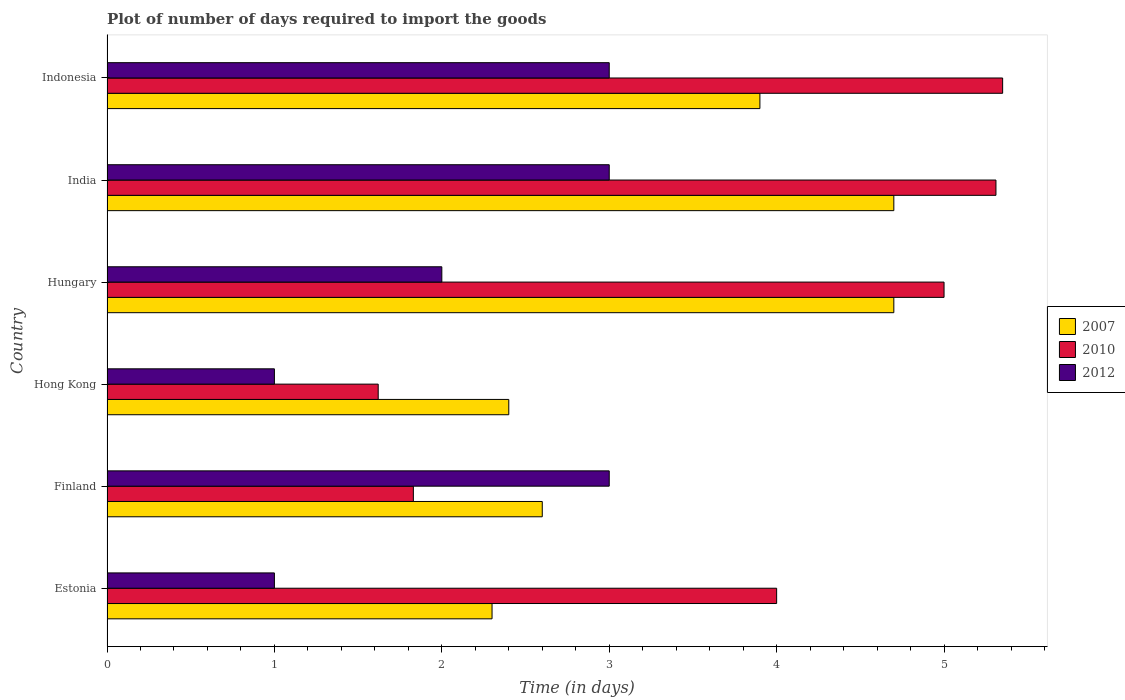How many different coloured bars are there?
Ensure brevity in your answer.  3. How many groups of bars are there?
Offer a terse response. 6. Are the number of bars per tick equal to the number of legend labels?
Provide a short and direct response. Yes. What is the label of the 6th group of bars from the top?
Keep it short and to the point. Estonia. What is the time required to import goods in 2010 in Finland?
Give a very brief answer. 1.83. Across all countries, what is the minimum time required to import goods in 2007?
Provide a succinct answer. 2.3. In which country was the time required to import goods in 2007 minimum?
Ensure brevity in your answer.  Estonia. What is the total time required to import goods in 2007 in the graph?
Make the answer very short. 20.6. What is the difference between the time required to import goods in 2010 in Estonia and that in India?
Your response must be concise. -1.31. What is the difference between the time required to import goods in 2007 in Hong Kong and the time required to import goods in 2012 in Hungary?
Your answer should be compact. 0.4. What is the average time required to import goods in 2007 per country?
Give a very brief answer. 3.43. What is the difference between the time required to import goods in 2012 and time required to import goods in 2007 in India?
Your answer should be compact. -1.7. In how many countries, is the time required to import goods in 2012 greater than 3 days?
Make the answer very short. 0. What is the ratio of the time required to import goods in 2007 in India to that in Indonesia?
Offer a terse response. 1.21. Is the time required to import goods in 2007 in Estonia less than that in Indonesia?
Offer a terse response. Yes. What is the difference between the highest and the second highest time required to import goods in 2007?
Offer a very short reply. 0. What is the difference between the highest and the lowest time required to import goods in 2012?
Make the answer very short. 2. What does the 1st bar from the top in Hong Kong represents?
Give a very brief answer. 2012. What does the 1st bar from the bottom in Hungary represents?
Offer a very short reply. 2007. Where does the legend appear in the graph?
Keep it short and to the point. Center right. How many legend labels are there?
Ensure brevity in your answer.  3. What is the title of the graph?
Make the answer very short. Plot of number of days required to import the goods. Does "1975" appear as one of the legend labels in the graph?
Offer a very short reply. No. What is the label or title of the X-axis?
Offer a very short reply. Time (in days). What is the label or title of the Y-axis?
Make the answer very short. Country. What is the Time (in days) of 2007 in Estonia?
Keep it short and to the point. 2.3. What is the Time (in days) in 2010 in Estonia?
Your answer should be compact. 4. What is the Time (in days) in 2010 in Finland?
Provide a succinct answer. 1.83. What is the Time (in days) in 2010 in Hong Kong?
Ensure brevity in your answer.  1.62. What is the Time (in days) in 2012 in Hong Kong?
Provide a short and direct response. 1. What is the Time (in days) of 2007 in India?
Provide a short and direct response. 4.7. What is the Time (in days) of 2010 in India?
Give a very brief answer. 5.31. What is the Time (in days) in 2012 in India?
Give a very brief answer. 3. What is the Time (in days) in 2007 in Indonesia?
Your response must be concise. 3.9. What is the Time (in days) in 2010 in Indonesia?
Ensure brevity in your answer.  5.35. Across all countries, what is the maximum Time (in days) in 2007?
Keep it short and to the point. 4.7. Across all countries, what is the maximum Time (in days) of 2010?
Provide a succinct answer. 5.35. Across all countries, what is the minimum Time (in days) of 2007?
Provide a short and direct response. 2.3. Across all countries, what is the minimum Time (in days) in 2010?
Your answer should be very brief. 1.62. Across all countries, what is the minimum Time (in days) in 2012?
Offer a terse response. 1. What is the total Time (in days) of 2007 in the graph?
Give a very brief answer. 20.6. What is the total Time (in days) in 2010 in the graph?
Offer a very short reply. 23.11. What is the total Time (in days) of 2012 in the graph?
Ensure brevity in your answer.  13. What is the difference between the Time (in days) in 2007 in Estonia and that in Finland?
Your answer should be very brief. -0.3. What is the difference between the Time (in days) in 2010 in Estonia and that in Finland?
Make the answer very short. 2.17. What is the difference between the Time (in days) in 2012 in Estonia and that in Finland?
Give a very brief answer. -2. What is the difference between the Time (in days) in 2010 in Estonia and that in Hong Kong?
Offer a very short reply. 2.38. What is the difference between the Time (in days) in 2010 in Estonia and that in Hungary?
Make the answer very short. -1. What is the difference between the Time (in days) in 2012 in Estonia and that in Hungary?
Your answer should be very brief. -1. What is the difference between the Time (in days) in 2007 in Estonia and that in India?
Give a very brief answer. -2.4. What is the difference between the Time (in days) of 2010 in Estonia and that in India?
Your answer should be compact. -1.31. What is the difference between the Time (in days) in 2012 in Estonia and that in India?
Make the answer very short. -2. What is the difference between the Time (in days) in 2010 in Estonia and that in Indonesia?
Give a very brief answer. -1.35. What is the difference between the Time (in days) in 2012 in Estonia and that in Indonesia?
Make the answer very short. -2. What is the difference between the Time (in days) of 2007 in Finland and that in Hong Kong?
Your answer should be compact. 0.2. What is the difference between the Time (in days) of 2010 in Finland and that in Hong Kong?
Your answer should be very brief. 0.21. What is the difference between the Time (in days) in 2010 in Finland and that in Hungary?
Keep it short and to the point. -3.17. What is the difference between the Time (in days) of 2010 in Finland and that in India?
Offer a terse response. -3.48. What is the difference between the Time (in days) of 2010 in Finland and that in Indonesia?
Offer a very short reply. -3.52. What is the difference between the Time (in days) of 2007 in Hong Kong and that in Hungary?
Offer a terse response. -2.3. What is the difference between the Time (in days) in 2010 in Hong Kong and that in Hungary?
Your answer should be compact. -3.38. What is the difference between the Time (in days) in 2007 in Hong Kong and that in India?
Give a very brief answer. -2.3. What is the difference between the Time (in days) of 2010 in Hong Kong and that in India?
Your answer should be very brief. -3.69. What is the difference between the Time (in days) of 2007 in Hong Kong and that in Indonesia?
Offer a terse response. -1.5. What is the difference between the Time (in days) of 2010 in Hong Kong and that in Indonesia?
Make the answer very short. -3.73. What is the difference between the Time (in days) in 2007 in Hungary and that in India?
Provide a short and direct response. 0. What is the difference between the Time (in days) of 2010 in Hungary and that in India?
Provide a short and direct response. -0.31. What is the difference between the Time (in days) of 2012 in Hungary and that in India?
Offer a terse response. -1. What is the difference between the Time (in days) in 2010 in Hungary and that in Indonesia?
Ensure brevity in your answer.  -0.35. What is the difference between the Time (in days) in 2010 in India and that in Indonesia?
Offer a terse response. -0.04. What is the difference between the Time (in days) in 2012 in India and that in Indonesia?
Your answer should be very brief. 0. What is the difference between the Time (in days) in 2007 in Estonia and the Time (in days) in 2010 in Finland?
Give a very brief answer. 0.47. What is the difference between the Time (in days) in 2007 in Estonia and the Time (in days) in 2012 in Finland?
Provide a short and direct response. -0.7. What is the difference between the Time (in days) in 2010 in Estonia and the Time (in days) in 2012 in Finland?
Provide a succinct answer. 1. What is the difference between the Time (in days) in 2007 in Estonia and the Time (in days) in 2010 in Hong Kong?
Give a very brief answer. 0.68. What is the difference between the Time (in days) of 2007 in Estonia and the Time (in days) of 2010 in Hungary?
Provide a short and direct response. -2.7. What is the difference between the Time (in days) of 2007 in Estonia and the Time (in days) of 2010 in India?
Ensure brevity in your answer.  -3.01. What is the difference between the Time (in days) in 2010 in Estonia and the Time (in days) in 2012 in India?
Your answer should be compact. 1. What is the difference between the Time (in days) of 2007 in Estonia and the Time (in days) of 2010 in Indonesia?
Your answer should be very brief. -3.05. What is the difference between the Time (in days) in 2007 in Estonia and the Time (in days) in 2012 in Indonesia?
Ensure brevity in your answer.  -0.7. What is the difference between the Time (in days) of 2010 in Estonia and the Time (in days) of 2012 in Indonesia?
Ensure brevity in your answer.  1. What is the difference between the Time (in days) of 2007 in Finland and the Time (in days) of 2010 in Hong Kong?
Make the answer very short. 0.98. What is the difference between the Time (in days) of 2007 in Finland and the Time (in days) of 2012 in Hong Kong?
Give a very brief answer. 1.6. What is the difference between the Time (in days) of 2010 in Finland and the Time (in days) of 2012 in Hong Kong?
Ensure brevity in your answer.  0.83. What is the difference between the Time (in days) of 2007 in Finland and the Time (in days) of 2012 in Hungary?
Offer a terse response. 0.6. What is the difference between the Time (in days) in 2010 in Finland and the Time (in days) in 2012 in Hungary?
Your response must be concise. -0.17. What is the difference between the Time (in days) of 2007 in Finland and the Time (in days) of 2010 in India?
Ensure brevity in your answer.  -2.71. What is the difference between the Time (in days) of 2010 in Finland and the Time (in days) of 2012 in India?
Provide a short and direct response. -1.17. What is the difference between the Time (in days) of 2007 in Finland and the Time (in days) of 2010 in Indonesia?
Your response must be concise. -2.75. What is the difference between the Time (in days) in 2010 in Finland and the Time (in days) in 2012 in Indonesia?
Keep it short and to the point. -1.17. What is the difference between the Time (in days) of 2007 in Hong Kong and the Time (in days) of 2012 in Hungary?
Make the answer very short. 0.4. What is the difference between the Time (in days) in 2010 in Hong Kong and the Time (in days) in 2012 in Hungary?
Your answer should be compact. -0.38. What is the difference between the Time (in days) in 2007 in Hong Kong and the Time (in days) in 2010 in India?
Offer a terse response. -2.91. What is the difference between the Time (in days) of 2010 in Hong Kong and the Time (in days) of 2012 in India?
Make the answer very short. -1.38. What is the difference between the Time (in days) in 2007 in Hong Kong and the Time (in days) in 2010 in Indonesia?
Give a very brief answer. -2.95. What is the difference between the Time (in days) of 2007 in Hong Kong and the Time (in days) of 2012 in Indonesia?
Offer a very short reply. -0.6. What is the difference between the Time (in days) of 2010 in Hong Kong and the Time (in days) of 2012 in Indonesia?
Provide a succinct answer. -1.38. What is the difference between the Time (in days) of 2007 in Hungary and the Time (in days) of 2010 in India?
Ensure brevity in your answer.  -0.61. What is the difference between the Time (in days) of 2007 in Hungary and the Time (in days) of 2010 in Indonesia?
Give a very brief answer. -0.65. What is the difference between the Time (in days) of 2007 in Hungary and the Time (in days) of 2012 in Indonesia?
Ensure brevity in your answer.  1.7. What is the difference between the Time (in days) of 2010 in Hungary and the Time (in days) of 2012 in Indonesia?
Offer a very short reply. 2. What is the difference between the Time (in days) of 2007 in India and the Time (in days) of 2010 in Indonesia?
Ensure brevity in your answer.  -0.65. What is the difference between the Time (in days) of 2007 in India and the Time (in days) of 2012 in Indonesia?
Provide a succinct answer. 1.7. What is the difference between the Time (in days) of 2010 in India and the Time (in days) of 2012 in Indonesia?
Ensure brevity in your answer.  2.31. What is the average Time (in days) of 2007 per country?
Offer a very short reply. 3.43. What is the average Time (in days) of 2010 per country?
Give a very brief answer. 3.85. What is the average Time (in days) of 2012 per country?
Provide a short and direct response. 2.17. What is the difference between the Time (in days) of 2007 and Time (in days) of 2010 in Finland?
Make the answer very short. 0.77. What is the difference between the Time (in days) in 2007 and Time (in days) in 2012 in Finland?
Make the answer very short. -0.4. What is the difference between the Time (in days) of 2010 and Time (in days) of 2012 in Finland?
Ensure brevity in your answer.  -1.17. What is the difference between the Time (in days) in 2007 and Time (in days) in 2010 in Hong Kong?
Your answer should be compact. 0.78. What is the difference between the Time (in days) of 2007 and Time (in days) of 2012 in Hong Kong?
Your answer should be compact. 1.4. What is the difference between the Time (in days) in 2010 and Time (in days) in 2012 in Hong Kong?
Your answer should be compact. 0.62. What is the difference between the Time (in days) of 2007 and Time (in days) of 2012 in Hungary?
Ensure brevity in your answer.  2.7. What is the difference between the Time (in days) of 2010 and Time (in days) of 2012 in Hungary?
Make the answer very short. 3. What is the difference between the Time (in days) of 2007 and Time (in days) of 2010 in India?
Give a very brief answer. -0.61. What is the difference between the Time (in days) of 2007 and Time (in days) of 2012 in India?
Your response must be concise. 1.7. What is the difference between the Time (in days) in 2010 and Time (in days) in 2012 in India?
Offer a terse response. 2.31. What is the difference between the Time (in days) of 2007 and Time (in days) of 2010 in Indonesia?
Your answer should be very brief. -1.45. What is the difference between the Time (in days) of 2007 and Time (in days) of 2012 in Indonesia?
Make the answer very short. 0.9. What is the difference between the Time (in days) in 2010 and Time (in days) in 2012 in Indonesia?
Give a very brief answer. 2.35. What is the ratio of the Time (in days) in 2007 in Estonia to that in Finland?
Offer a terse response. 0.88. What is the ratio of the Time (in days) in 2010 in Estonia to that in Finland?
Provide a short and direct response. 2.19. What is the ratio of the Time (in days) of 2007 in Estonia to that in Hong Kong?
Provide a succinct answer. 0.96. What is the ratio of the Time (in days) of 2010 in Estonia to that in Hong Kong?
Offer a very short reply. 2.47. What is the ratio of the Time (in days) in 2012 in Estonia to that in Hong Kong?
Keep it short and to the point. 1. What is the ratio of the Time (in days) of 2007 in Estonia to that in Hungary?
Offer a very short reply. 0.49. What is the ratio of the Time (in days) of 2007 in Estonia to that in India?
Provide a short and direct response. 0.49. What is the ratio of the Time (in days) in 2010 in Estonia to that in India?
Make the answer very short. 0.75. What is the ratio of the Time (in days) in 2012 in Estonia to that in India?
Offer a terse response. 0.33. What is the ratio of the Time (in days) in 2007 in Estonia to that in Indonesia?
Your response must be concise. 0.59. What is the ratio of the Time (in days) in 2010 in Estonia to that in Indonesia?
Offer a terse response. 0.75. What is the ratio of the Time (in days) of 2007 in Finland to that in Hong Kong?
Offer a very short reply. 1.08. What is the ratio of the Time (in days) of 2010 in Finland to that in Hong Kong?
Provide a succinct answer. 1.13. What is the ratio of the Time (in days) in 2012 in Finland to that in Hong Kong?
Ensure brevity in your answer.  3. What is the ratio of the Time (in days) of 2007 in Finland to that in Hungary?
Provide a short and direct response. 0.55. What is the ratio of the Time (in days) in 2010 in Finland to that in Hungary?
Keep it short and to the point. 0.37. What is the ratio of the Time (in days) in 2007 in Finland to that in India?
Offer a very short reply. 0.55. What is the ratio of the Time (in days) in 2010 in Finland to that in India?
Offer a terse response. 0.34. What is the ratio of the Time (in days) of 2012 in Finland to that in India?
Make the answer very short. 1. What is the ratio of the Time (in days) of 2007 in Finland to that in Indonesia?
Give a very brief answer. 0.67. What is the ratio of the Time (in days) of 2010 in Finland to that in Indonesia?
Your answer should be very brief. 0.34. What is the ratio of the Time (in days) of 2007 in Hong Kong to that in Hungary?
Ensure brevity in your answer.  0.51. What is the ratio of the Time (in days) of 2010 in Hong Kong to that in Hungary?
Your answer should be very brief. 0.32. What is the ratio of the Time (in days) in 2012 in Hong Kong to that in Hungary?
Your answer should be compact. 0.5. What is the ratio of the Time (in days) of 2007 in Hong Kong to that in India?
Provide a short and direct response. 0.51. What is the ratio of the Time (in days) in 2010 in Hong Kong to that in India?
Provide a short and direct response. 0.31. What is the ratio of the Time (in days) of 2007 in Hong Kong to that in Indonesia?
Provide a short and direct response. 0.62. What is the ratio of the Time (in days) in 2010 in Hong Kong to that in Indonesia?
Provide a succinct answer. 0.3. What is the ratio of the Time (in days) of 2012 in Hong Kong to that in Indonesia?
Your answer should be compact. 0.33. What is the ratio of the Time (in days) of 2007 in Hungary to that in India?
Keep it short and to the point. 1. What is the ratio of the Time (in days) in 2010 in Hungary to that in India?
Offer a very short reply. 0.94. What is the ratio of the Time (in days) of 2007 in Hungary to that in Indonesia?
Provide a succinct answer. 1.21. What is the ratio of the Time (in days) of 2010 in Hungary to that in Indonesia?
Make the answer very short. 0.93. What is the ratio of the Time (in days) in 2007 in India to that in Indonesia?
Give a very brief answer. 1.21. What is the difference between the highest and the second highest Time (in days) in 2010?
Offer a very short reply. 0.04. What is the difference between the highest and the lowest Time (in days) in 2007?
Your answer should be compact. 2.4. What is the difference between the highest and the lowest Time (in days) of 2010?
Ensure brevity in your answer.  3.73. What is the difference between the highest and the lowest Time (in days) in 2012?
Provide a short and direct response. 2. 